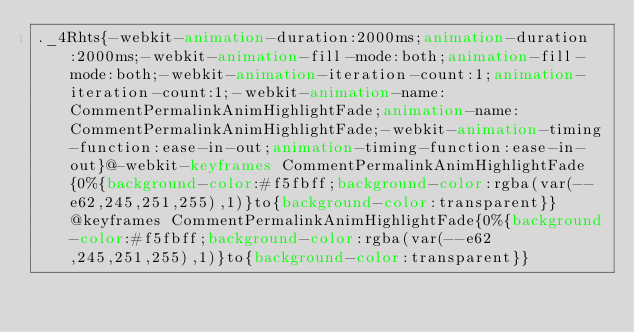Convert code to text. <code><loc_0><loc_0><loc_500><loc_500><_CSS_>._4Rhts{-webkit-animation-duration:2000ms;animation-duration:2000ms;-webkit-animation-fill-mode:both;animation-fill-mode:both;-webkit-animation-iteration-count:1;animation-iteration-count:1;-webkit-animation-name:CommentPermalinkAnimHighlightFade;animation-name:CommentPermalinkAnimHighlightFade;-webkit-animation-timing-function:ease-in-out;animation-timing-function:ease-in-out}@-webkit-keyframes CommentPermalinkAnimHighlightFade{0%{background-color:#f5fbff;background-color:rgba(var(--e62,245,251,255),1)}to{background-color:transparent}}@keyframes CommentPermalinkAnimHighlightFade{0%{background-color:#f5fbff;background-color:rgba(var(--e62,245,251,255),1)}to{background-color:transparent}}</code> 